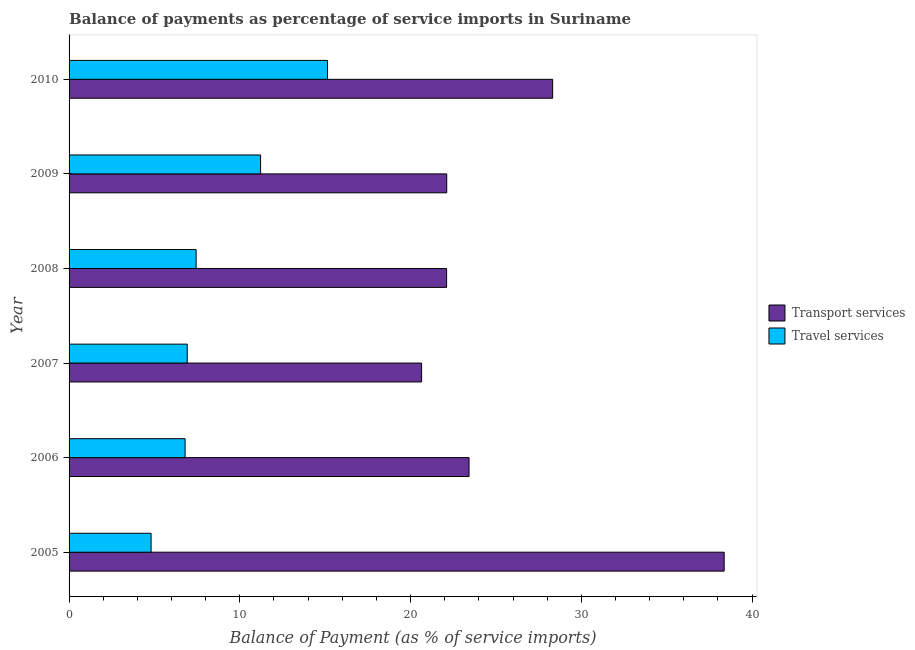How many different coloured bars are there?
Offer a terse response. 2. Are the number of bars per tick equal to the number of legend labels?
Offer a very short reply. Yes. Are the number of bars on each tick of the Y-axis equal?
Offer a very short reply. Yes. What is the label of the 6th group of bars from the top?
Offer a very short reply. 2005. What is the balance of payments of travel services in 2008?
Provide a succinct answer. 7.44. Across all years, what is the maximum balance of payments of travel services?
Provide a succinct answer. 15.14. Across all years, what is the minimum balance of payments of travel services?
Your answer should be very brief. 4.8. In which year was the balance of payments of travel services maximum?
Offer a terse response. 2010. What is the total balance of payments of transport services in the graph?
Your answer should be compact. 154.98. What is the difference between the balance of payments of travel services in 2005 and that in 2007?
Your answer should be compact. -2.12. What is the difference between the balance of payments of transport services in 2010 and the balance of payments of travel services in 2007?
Your answer should be very brief. 21.4. What is the average balance of payments of travel services per year?
Your response must be concise. 8.72. In the year 2007, what is the difference between the balance of payments of travel services and balance of payments of transport services?
Offer a terse response. -13.72. What is the ratio of the balance of payments of transport services in 2009 to that in 2010?
Ensure brevity in your answer.  0.78. Is the balance of payments of transport services in 2005 less than that in 2008?
Make the answer very short. No. Is the difference between the balance of payments of transport services in 2007 and 2008 greater than the difference between the balance of payments of travel services in 2007 and 2008?
Offer a terse response. No. What is the difference between the highest and the second highest balance of payments of travel services?
Ensure brevity in your answer.  3.92. What is the difference between the highest and the lowest balance of payments of travel services?
Make the answer very short. 10.33. In how many years, is the balance of payments of transport services greater than the average balance of payments of transport services taken over all years?
Offer a terse response. 2. What does the 1st bar from the top in 2006 represents?
Provide a succinct answer. Travel services. What does the 1st bar from the bottom in 2005 represents?
Your answer should be very brief. Transport services. How many years are there in the graph?
Keep it short and to the point. 6. What is the difference between two consecutive major ticks on the X-axis?
Give a very brief answer. 10. Does the graph contain any zero values?
Offer a very short reply. No. Does the graph contain grids?
Provide a short and direct response. No. How are the legend labels stacked?
Offer a terse response. Vertical. What is the title of the graph?
Your answer should be very brief. Balance of payments as percentage of service imports in Suriname. Does "Not attending school" appear as one of the legend labels in the graph?
Provide a succinct answer. No. What is the label or title of the X-axis?
Provide a succinct answer. Balance of Payment (as % of service imports). What is the Balance of Payment (as % of service imports) in Transport services in 2005?
Provide a succinct answer. 38.37. What is the Balance of Payment (as % of service imports) of Travel services in 2005?
Make the answer very short. 4.8. What is the Balance of Payment (as % of service imports) of Transport services in 2006?
Your answer should be compact. 23.42. What is the Balance of Payment (as % of service imports) of Travel services in 2006?
Keep it short and to the point. 6.8. What is the Balance of Payment (as % of service imports) of Transport services in 2007?
Your response must be concise. 20.64. What is the Balance of Payment (as % of service imports) in Travel services in 2007?
Your response must be concise. 6.92. What is the Balance of Payment (as % of service imports) of Transport services in 2008?
Your answer should be compact. 22.11. What is the Balance of Payment (as % of service imports) in Travel services in 2008?
Your answer should be compact. 7.44. What is the Balance of Payment (as % of service imports) of Transport services in 2009?
Your answer should be compact. 22.12. What is the Balance of Payment (as % of service imports) in Travel services in 2009?
Keep it short and to the point. 11.22. What is the Balance of Payment (as % of service imports) in Transport services in 2010?
Offer a very short reply. 28.32. What is the Balance of Payment (as % of service imports) of Travel services in 2010?
Make the answer very short. 15.14. Across all years, what is the maximum Balance of Payment (as % of service imports) in Transport services?
Give a very brief answer. 38.37. Across all years, what is the maximum Balance of Payment (as % of service imports) in Travel services?
Provide a succinct answer. 15.14. Across all years, what is the minimum Balance of Payment (as % of service imports) in Transport services?
Your response must be concise. 20.64. Across all years, what is the minimum Balance of Payment (as % of service imports) of Travel services?
Keep it short and to the point. 4.8. What is the total Balance of Payment (as % of service imports) of Transport services in the graph?
Your answer should be very brief. 154.98. What is the total Balance of Payment (as % of service imports) in Travel services in the graph?
Your answer should be very brief. 52.31. What is the difference between the Balance of Payment (as % of service imports) of Transport services in 2005 and that in 2006?
Provide a short and direct response. 14.94. What is the difference between the Balance of Payment (as % of service imports) in Travel services in 2005 and that in 2006?
Your answer should be compact. -1.99. What is the difference between the Balance of Payment (as % of service imports) of Transport services in 2005 and that in 2007?
Offer a very short reply. 17.72. What is the difference between the Balance of Payment (as % of service imports) in Travel services in 2005 and that in 2007?
Offer a very short reply. -2.12. What is the difference between the Balance of Payment (as % of service imports) of Transport services in 2005 and that in 2008?
Keep it short and to the point. 16.26. What is the difference between the Balance of Payment (as % of service imports) of Travel services in 2005 and that in 2008?
Give a very brief answer. -2.64. What is the difference between the Balance of Payment (as % of service imports) in Transport services in 2005 and that in 2009?
Offer a terse response. 16.25. What is the difference between the Balance of Payment (as % of service imports) of Travel services in 2005 and that in 2009?
Your answer should be very brief. -6.41. What is the difference between the Balance of Payment (as % of service imports) in Transport services in 2005 and that in 2010?
Ensure brevity in your answer.  10.05. What is the difference between the Balance of Payment (as % of service imports) of Travel services in 2005 and that in 2010?
Make the answer very short. -10.33. What is the difference between the Balance of Payment (as % of service imports) of Transport services in 2006 and that in 2007?
Your answer should be compact. 2.78. What is the difference between the Balance of Payment (as % of service imports) in Travel services in 2006 and that in 2007?
Make the answer very short. -0.12. What is the difference between the Balance of Payment (as % of service imports) of Transport services in 2006 and that in 2008?
Provide a short and direct response. 1.31. What is the difference between the Balance of Payment (as % of service imports) of Travel services in 2006 and that in 2008?
Provide a succinct answer. -0.65. What is the difference between the Balance of Payment (as % of service imports) in Transport services in 2006 and that in 2009?
Provide a succinct answer. 1.31. What is the difference between the Balance of Payment (as % of service imports) of Travel services in 2006 and that in 2009?
Give a very brief answer. -4.42. What is the difference between the Balance of Payment (as % of service imports) of Transport services in 2006 and that in 2010?
Make the answer very short. -4.9. What is the difference between the Balance of Payment (as % of service imports) in Travel services in 2006 and that in 2010?
Your answer should be compact. -8.34. What is the difference between the Balance of Payment (as % of service imports) of Transport services in 2007 and that in 2008?
Make the answer very short. -1.46. What is the difference between the Balance of Payment (as % of service imports) in Travel services in 2007 and that in 2008?
Your answer should be very brief. -0.52. What is the difference between the Balance of Payment (as % of service imports) of Transport services in 2007 and that in 2009?
Ensure brevity in your answer.  -1.47. What is the difference between the Balance of Payment (as % of service imports) in Travel services in 2007 and that in 2009?
Offer a terse response. -4.3. What is the difference between the Balance of Payment (as % of service imports) of Transport services in 2007 and that in 2010?
Offer a terse response. -7.68. What is the difference between the Balance of Payment (as % of service imports) of Travel services in 2007 and that in 2010?
Provide a short and direct response. -8.21. What is the difference between the Balance of Payment (as % of service imports) of Transport services in 2008 and that in 2009?
Provide a succinct answer. -0.01. What is the difference between the Balance of Payment (as % of service imports) in Travel services in 2008 and that in 2009?
Your response must be concise. -3.78. What is the difference between the Balance of Payment (as % of service imports) of Transport services in 2008 and that in 2010?
Your answer should be compact. -6.21. What is the difference between the Balance of Payment (as % of service imports) of Travel services in 2008 and that in 2010?
Your answer should be compact. -7.69. What is the difference between the Balance of Payment (as % of service imports) in Transport services in 2009 and that in 2010?
Provide a succinct answer. -6.2. What is the difference between the Balance of Payment (as % of service imports) in Travel services in 2009 and that in 2010?
Your answer should be compact. -3.92. What is the difference between the Balance of Payment (as % of service imports) in Transport services in 2005 and the Balance of Payment (as % of service imports) in Travel services in 2006?
Your answer should be compact. 31.57. What is the difference between the Balance of Payment (as % of service imports) in Transport services in 2005 and the Balance of Payment (as % of service imports) in Travel services in 2007?
Offer a terse response. 31.45. What is the difference between the Balance of Payment (as % of service imports) of Transport services in 2005 and the Balance of Payment (as % of service imports) of Travel services in 2008?
Provide a succinct answer. 30.92. What is the difference between the Balance of Payment (as % of service imports) of Transport services in 2005 and the Balance of Payment (as % of service imports) of Travel services in 2009?
Your answer should be compact. 27.15. What is the difference between the Balance of Payment (as % of service imports) of Transport services in 2005 and the Balance of Payment (as % of service imports) of Travel services in 2010?
Your response must be concise. 23.23. What is the difference between the Balance of Payment (as % of service imports) in Transport services in 2006 and the Balance of Payment (as % of service imports) in Travel services in 2007?
Offer a terse response. 16.5. What is the difference between the Balance of Payment (as % of service imports) in Transport services in 2006 and the Balance of Payment (as % of service imports) in Travel services in 2008?
Give a very brief answer. 15.98. What is the difference between the Balance of Payment (as % of service imports) of Transport services in 2006 and the Balance of Payment (as % of service imports) of Travel services in 2009?
Provide a succinct answer. 12.21. What is the difference between the Balance of Payment (as % of service imports) of Transport services in 2006 and the Balance of Payment (as % of service imports) of Travel services in 2010?
Your answer should be very brief. 8.29. What is the difference between the Balance of Payment (as % of service imports) in Transport services in 2007 and the Balance of Payment (as % of service imports) in Travel services in 2008?
Make the answer very short. 13.2. What is the difference between the Balance of Payment (as % of service imports) of Transport services in 2007 and the Balance of Payment (as % of service imports) of Travel services in 2009?
Keep it short and to the point. 9.43. What is the difference between the Balance of Payment (as % of service imports) in Transport services in 2007 and the Balance of Payment (as % of service imports) in Travel services in 2010?
Provide a short and direct response. 5.51. What is the difference between the Balance of Payment (as % of service imports) of Transport services in 2008 and the Balance of Payment (as % of service imports) of Travel services in 2009?
Provide a succinct answer. 10.89. What is the difference between the Balance of Payment (as % of service imports) in Transport services in 2008 and the Balance of Payment (as % of service imports) in Travel services in 2010?
Give a very brief answer. 6.97. What is the difference between the Balance of Payment (as % of service imports) of Transport services in 2009 and the Balance of Payment (as % of service imports) of Travel services in 2010?
Ensure brevity in your answer.  6.98. What is the average Balance of Payment (as % of service imports) of Transport services per year?
Your response must be concise. 25.83. What is the average Balance of Payment (as % of service imports) of Travel services per year?
Give a very brief answer. 8.72. In the year 2005, what is the difference between the Balance of Payment (as % of service imports) of Transport services and Balance of Payment (as % of service imports) of Travel services?
Ensure brevity in your answer.  33.56. In the year 2006, what is the difference between the Balance of Payment (as % of service imports) of Transport services and Balance of Payment (as % of service imports) of Travel services?
Your answer should be compact. 16.63. In the year 2007, what is the difference between the Balance of Payment (as % of service imports) of Transport services and Balance of Payment (as % of service imports) of Travel services?
Ensure brevity in your answer.  13.72. In the year 2008, what is the difference between the Balance of Payment (as % of service imports) of Transport services and Balance of Payment (as % of service imports) of Travel services?
Offer a very short reply. 14.67. In the year 2009, what is the difference between the Balance of Payment (as % of service imports) in Transport services and Balance of Payment (as % of service imports) in Travel services?
Your response must be concise. 10.9. In the year 2010, what is the difference between the Balance of Payment (as % of service imports) of Transport services and Balance of Payment (as % of service imports) of Travel services?
Offer a very short reply. 13.19. What is the ratio of the Balance of Payment (as % of service imports) in Transport services in 2005 to that in 2006?
Your answer should be very brief. 1.64. What is the ratio of the Balance of Payment (as % of service imports) of Travel services in 2005 to that in 2006?
Your answer should be compact. 0.71. What is the ratio of the Balance of Payment (as % of service imports) in Transport services in 2005 to that in 2007?
Give a very brief answer. 1.86. What is the ratio of the Balance of Payment (as % of service imports) in Travel services in 2005 to that in 2007?
Make the answer very short. 0.69. What is the ratio of the Balance of Payment (as % of service imports) of Transport services in 2005 to that in 2008?
Your answer should be very brief. 1.74. What is the ratio of the Balance of Payment (as % of service imports) of Travel services in 2005 to that in 2008?
Offer a terse response. 0.65. What is the ratio of the Balance of Payment (as % of service imports) in Transport services in 2005 to that in 2009?
Ensure brevity in your answer.  1.73. What is the ratio of the Balance of Payment (as % of service imports) of Travel services in 2005 to that in 2009?
Give a very brief answer. 0.43. What is the ratio of the Balance of Payment (as % of service imports) of Transport services in 2005 to that in 2010?
Make the answer very short. 1.35. What is the ratio of the Balance of Payment (as % of service imports) of Travel services in 2005 to that in 2010?
Provide a succinct answer. 0.32. What is the ratio of the Balance of Payment (as % of service imports) in Transport services in 2006 to that in 2007?
Make the answer very short. 1.13. What is the ratio of the Balance of Payment (as % of service imports) of Travel services in 2006 to that in 2007?
Ensure brevity in your answer.  0.98. What is the ratio of the Balance of Payment (as % of service imports) in Transport services in 2006 to that in 2008?
Your answer should be very brief. 1.06. What is the ratio of the Balance of Payment (as % of service imports) in Travel services in 2006 to that in 2008?
Offer a very short reply. 0.91. What is the ratio of the Balance of Payment (as % of service imports) in Transport services in 2006 to that in 2009?
Give a very brief answer. 1.06. What is the ratio of the Balance of Payment (as % of service imports) in Travel services in 2006 to that in 2009?
Your answer should be very brief. 0.61. What is the ratio of the Balance of Payment (as % of service imports) of Transport services in 2006 to that in 2010?
Offer a very short reply. 0.83. What is the ratio of the Balance of Payment (as % of service imports) in Travel services in 2006 to that in 2010?
Keep it short and to the point. 0.45. What is the ratio of the Balance of Payment (as % of service imports) in Transport services in 2007 to that in 2008?
Ensure brevity in your answer.  0.93. What is the ratio of the Balance of Payment (as % of service imports) in Transport services in 2007 to that in 2009?
Your response must be concise. 0.93. What is the ratio of the Balance of Payment (as % of service imports) of Travel services in 2007 to that in 2009?
Provide a short and direct response. 0.62. What is the ratio of the Balance of Payment (as % of service imports) in Transport services in 2007 to that in 2010?
Keep it short and to the point. 0.73. What is the ratio of the Balance of Payment (as % of service imports) of Travel services in 2007 to that in 2010?
Offer a terse response. 0.46. What is the ratio of the Balance of Payment (as % of service imports) in Transport services in 2008 to that in 2009?
Your answer should be very brief. 1. What is the ratio of the Balance of Payment (as % of service imports) in Travel services in 2008 to that in 2009?
Make the answer very short. 0.66. What is the ratio of the Balance of Payment (as % of service imports) in Transport services in 2008 to that in 2010?
Make the answer very short. 0.78. What is the ratio of the Balance of Payment (as % of service imports) in Travel services in 2008 to that in 2010?
Provide a short and direct response. 0.49. What is the ratio of the Balance of Payment (as % of service imports) in Transport services in 2009 to that in 2010?
Offer a terse response. 0.78. What is the ratio of the Balance of Payment (as % of service imports) of Travel services in 2009 to that in 2010?
Provide a succinct answer. 0.74. What is the difference between the highest and the second highest Balance of Payment (as % of service imports) of Transport services?
Provide a short and direct response. 10.05. What is the difference between the highest and the second highest Balance of Payment (as % of service imports) in Travel services?
Ensure brevity in your answer.  3.92. What is the difference between the highest and the lowest Balance of Payment (as % of service imports) of Transport services?
Provide a succinct answer. 17.72. What is the difference between the highest and the lowest Balance of Payment (as % of service imports) in Travel services?
Keep it short and to the point. 10.33. 